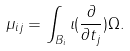<formula> <loc_0><loc_0><loc_500><loc_500>\mu _ { i j } = \int _ { B _ { i } } \iota ( \frac { \partial } { \partial t _ { j } } ) \Omega .</formula> 